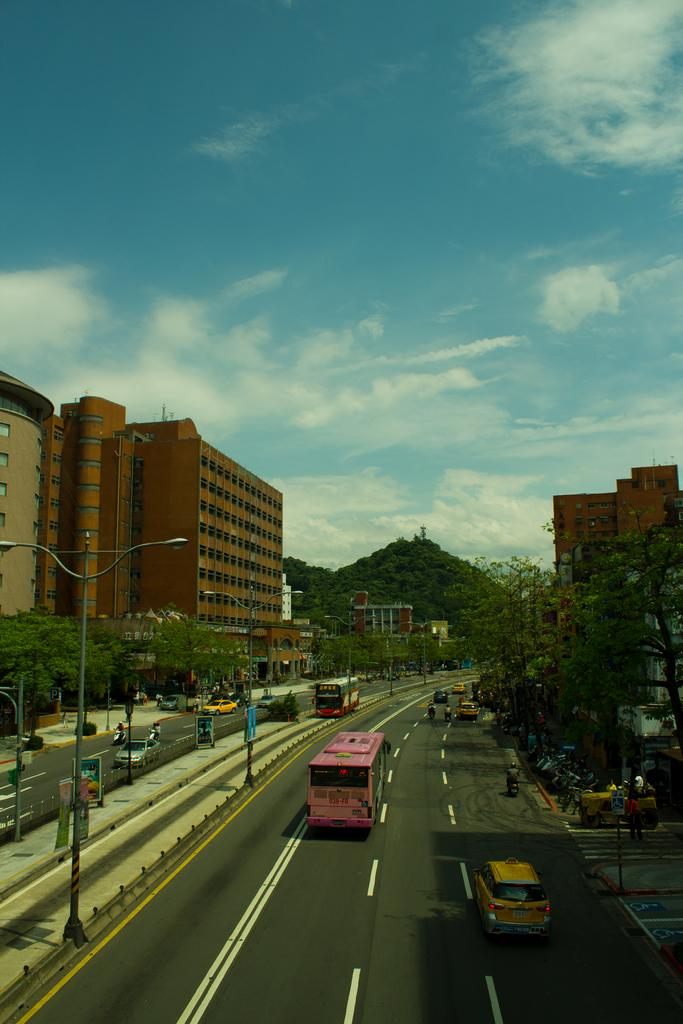What types of objects can be seen in the image? There are vehicles, buildings, people, poles, trees, and hills visible in the image. What else can be seen in the image besides the objects mentioned? There are boards, the ground, and the sky visible in the image. What is the condition of the sky in the image? The sky is visible in the image, and clouds are present. Can you tell me how many pickles are on the trees in the image? There are no pickles present in the image; it features vehicles, buildings, people, poles, trees, hills, boards, the ground, and the sky. What type of squirrel can be seen climbing the poles in the image? There are no squirrels present in the image; it features vehicles, buildings, people, poles, trees, hills, boards, the ground, and the sky. 